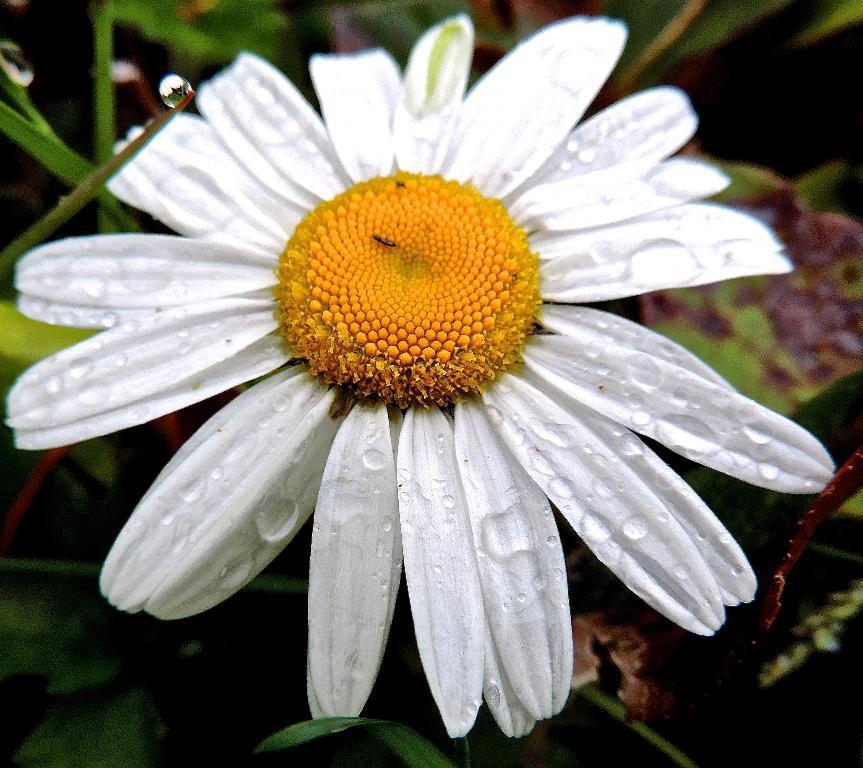In one or two sentences, can you explain what this image depicts? In this image I can see a yellow and white colour flower. I can also see green color leaves in the background and I can see this image is little bit blurry from background. 